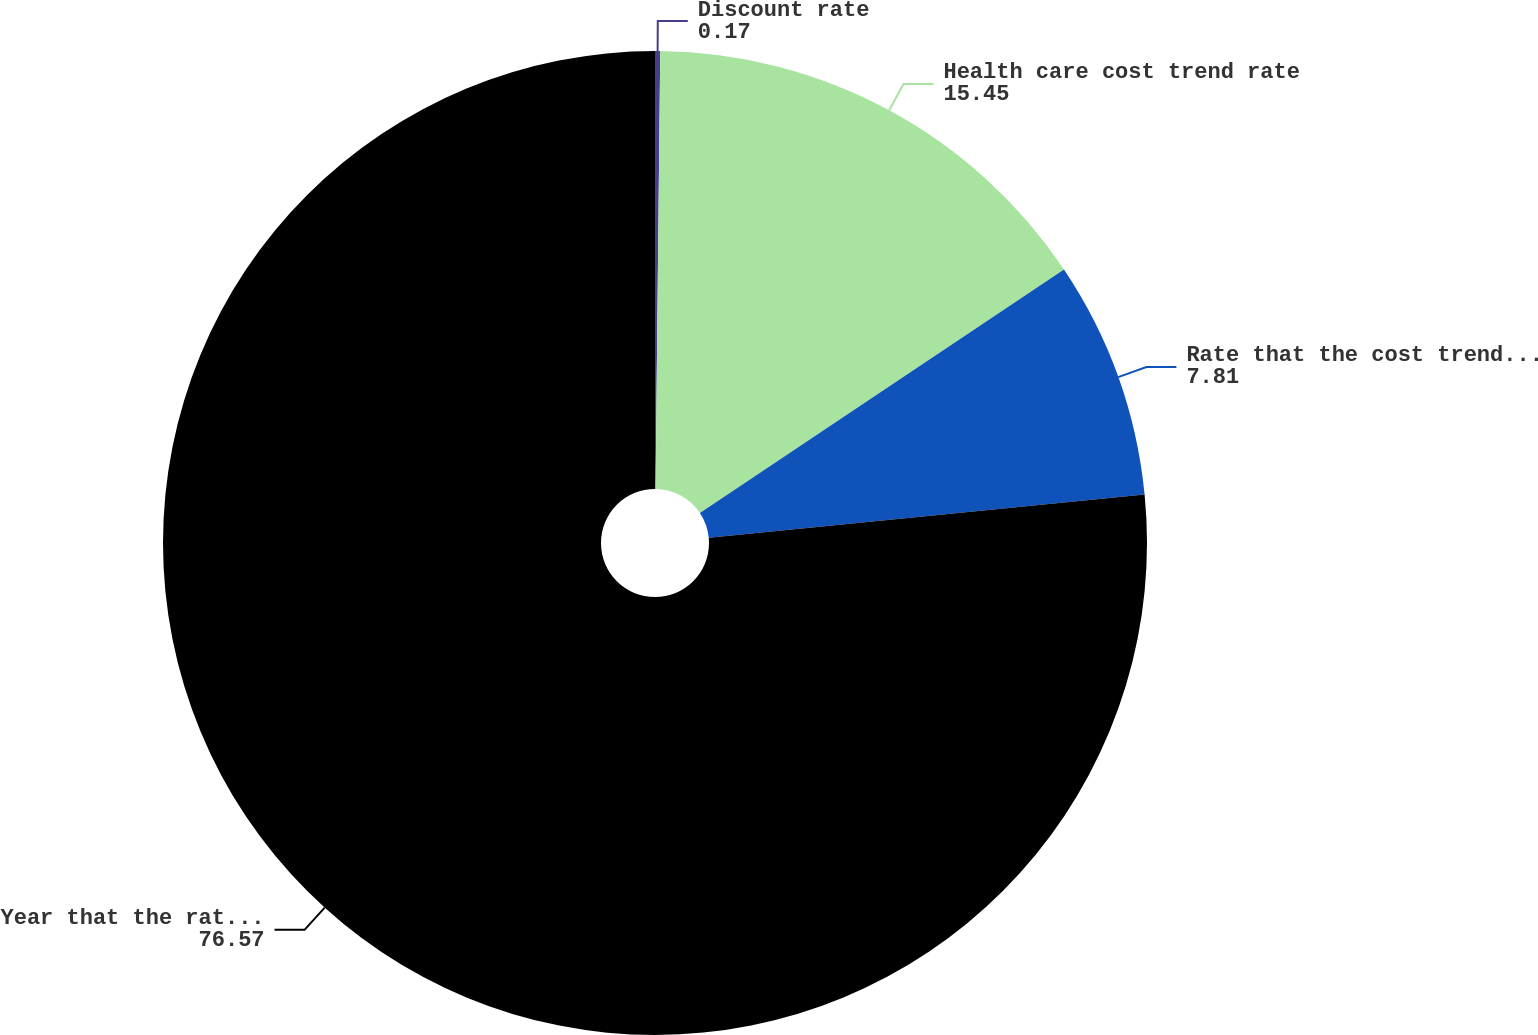<chart> <loc_0><loc_0><loc_500><loc_500><pie_chart><fcel>Discount rate<fcel>Health care cost trend rate<fcel>Rate that the cost trend rate<fcel>Year that the rate reaches the<nl><fcel>0.17%<fcel>15.45%<fcel>7.81%<fcel>76.57%<nl></chart> 